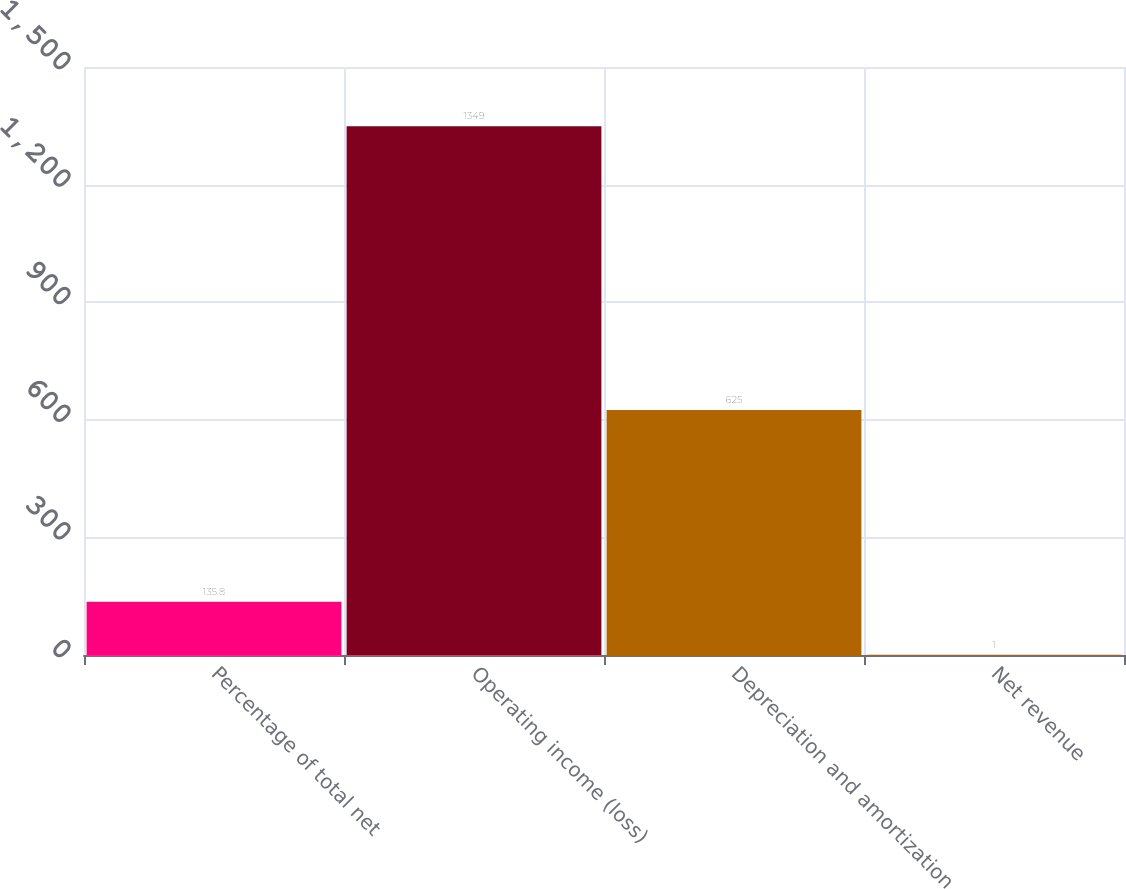<chart> <loc_0><loc_0><loc_500><loc_500><bar_chart><fcel>Percentage of total net<fcel>Operating income (loss)<fcel>Depreciation and amortization<fcel>Net revenue<nl><fcel>135.8<fcel>1349<fcel>625<fcel>1<nl></chart> 